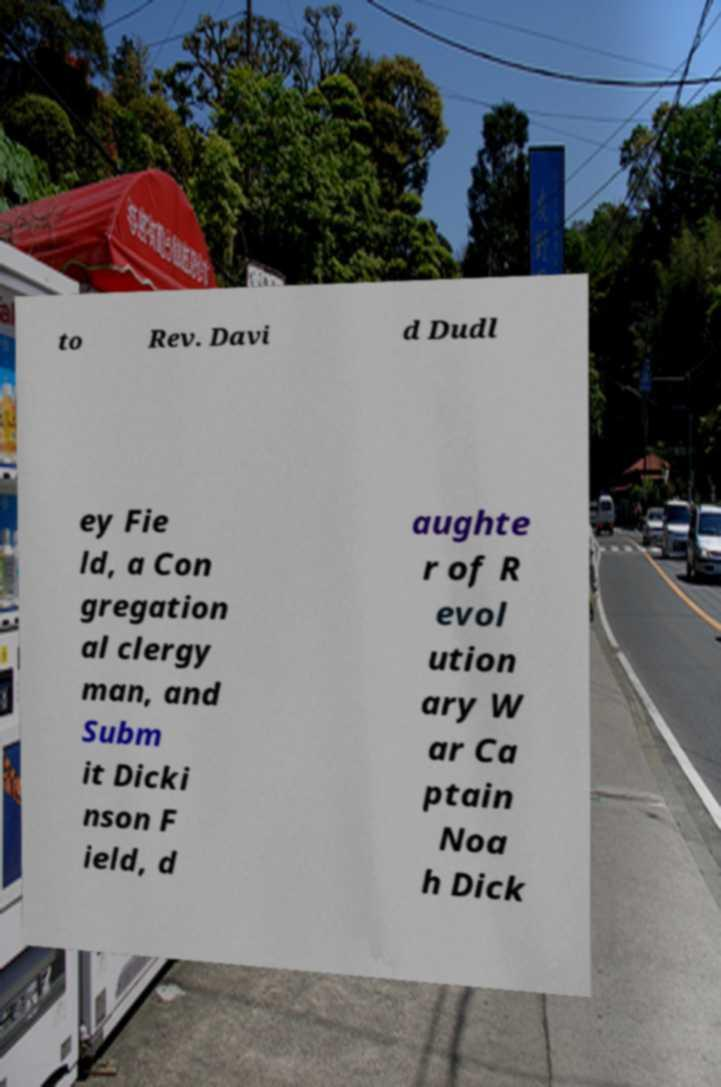I need the written content from this picture converted into text. Can you do that? to Rev. Davi d Dudl ey Fie ld, a Con gregation al clergy man, and Subm it Dicki nson F ield, d aughte r of R evol ution ary W ar Ca ptain Noa h Dick 